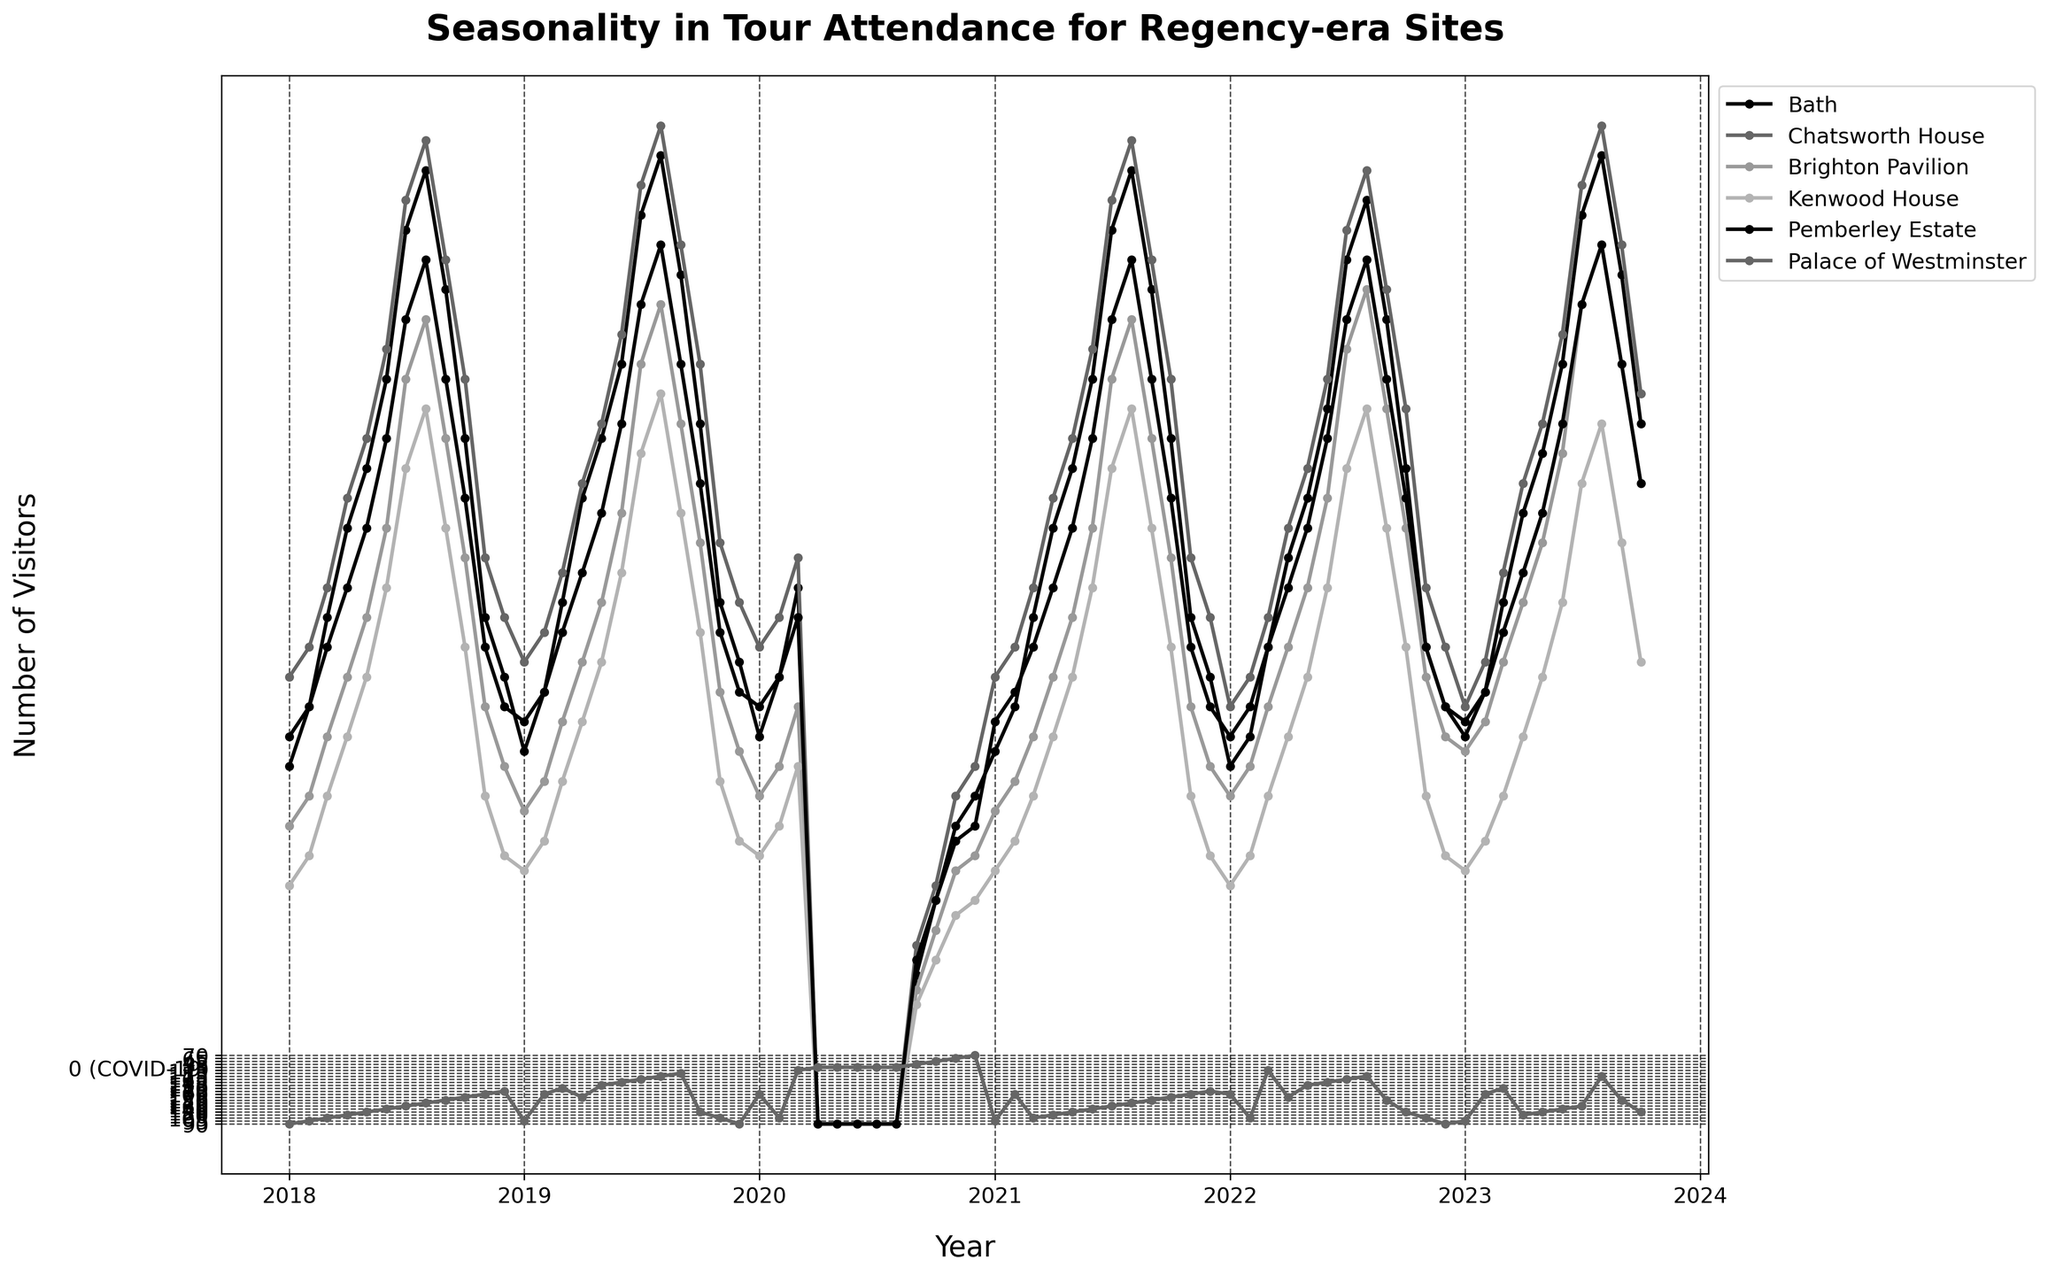What is the title of the plot? The title is displayed prominently at the top of the plot.
Answer: Seasonality in Tour Attendance for Regency-era Sites What months in 2020 had zero tour attendance due to COVID-19? By observing the plot, the months with zero attendance show flat lines at the bottom of the graph.
Answer: April, May, June, July, August Which site had the highest visitor count in August 2023? The highest point for each site in August 2023 can be seen clearly, where the plotted line reaches its peak.
Answer: Brighton Pavilion Comparing July 2018 and July 2019, does the tour attendance for Bath increase, decrease, or stay the same? Track the vertical position of the data points for Bath in both July 2018 and July 2019.
Answer: Increase Which site shows the most consistent seasonal pattern in attendance across the 5 years? Consistent patterns are identified by observing sites that have regular peaks and lows each year.
Answer: Pemberley Estate What is the approximate visitor count at Chatsworth House in December 2018? Locate the position of the data point for Chatsworth House in December 2018 and read the value from the y-axis.
Answer: 170 How does visitor attendance at Kenwood House in March 2021 compare to March 2022? Compare the data points for Kenwood House in March of 2021 and 2022 to see which is higher.
Answer: Lower in 2021 Which site had the highest range of tour attendance over the 5-year period? The range is the difference between the highest and lowest attendance values; identify the largest gap between these points for each site.
Answer: Brighton Pavilion What was the trend in visitor numbers for the Palace of Westminster from July to December 2022? Observe the plotted points for Palace of Westminster from July to December 2022, noting whether they rise, fall, or stay constant.
Answer: Decreasing What significant event is indicated by the drastic drop in tour attendance across all sites in April 2020? A sharp decline to zero attendance for all sites suggests a significant external factor.
Answer: COVID-19 Pandemic 